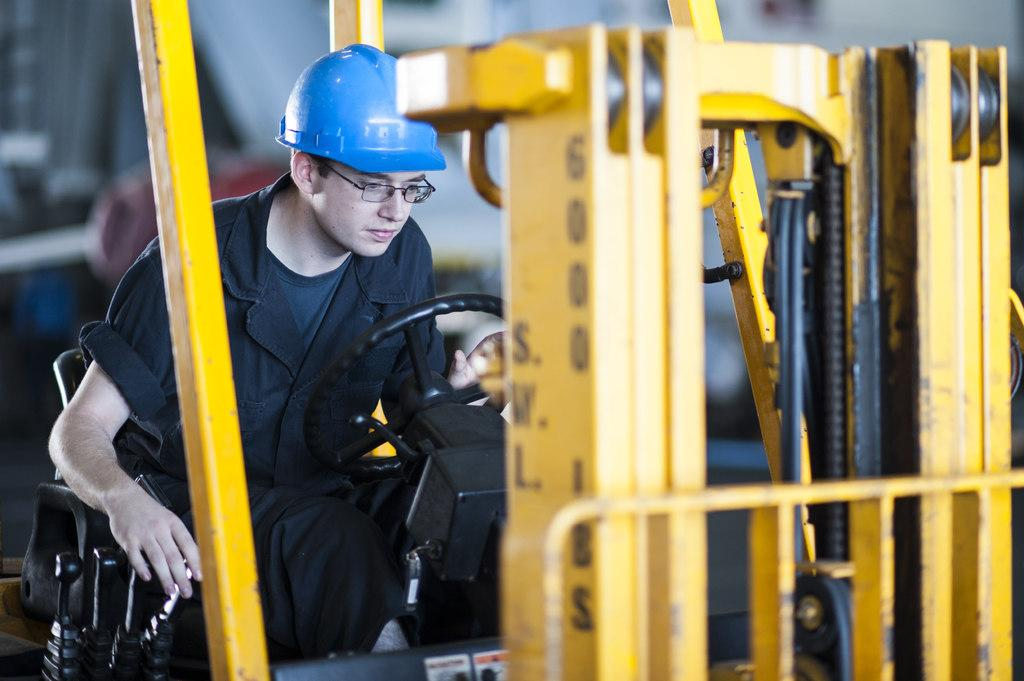What can be observed about the background of the image? The background of the image is blurred. Can you describe the person in the image? There is a person in the image, and they are wearing spectacles and a helmet. What is the person doing in the image? The person is sitting on a vehicle. Is there any text visible in the image? Yes, there is text on a yellow rod in the image. Can you tell me how many geese are flying in the background of the image? There are no geese visible in the image; the background is blurred. What type of haircut does the person in the image have? The person in the image is wearing a helmet, so it is not possible to determine their haircut from the image. 